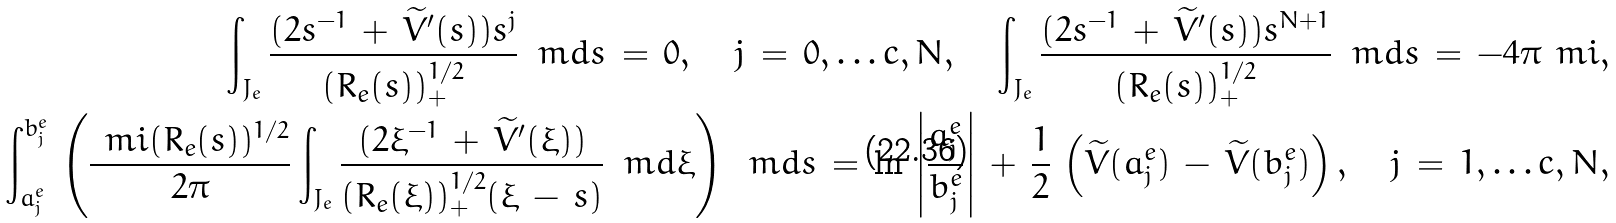Convert formula to latex. <formula><loc_0><loc_0><loc_500><loc_500>\int _ { J _ { e } } \frac { ( 2 s ^ { - 1 } \, + \, \widetilde { V } ^ { \prime } ( s ) ) s ^ { j } } { ( R _ { e } ( s ) ) ^ { 1 / 2 } _ { + } } \, \ m d s \, = \, 0 , \quad j \, = \, 0 , \dots c , N , \quad \int _ { J _ { e } } \frac { ( 2 s ^ { - 1 } \, + \, \widetilde { V } ^ { \prime } ( s ) ) s ^ { N + 1 } } { ( R _ { e } ( s ) ) ^ { 1 / 2 } _ { + } } \, \ m d s \, = \, - 4 \pi \ m i , \\ \int _ { a _ { j } ^ { e } } ^ { b _ { j } ^ { e } } \, \left ( \frac { \ m i ( R _ { e } ( s ) ) ^ { 1 / 2 } } { 2 \pi } \int _ { J _ { e } } \frac { ( 2 \xi ^ { - 1 } \, + \, \widetilde { V } ^ { \prime } ( \xi ) ) } { ( R _ { e } ( \xi ) ) ^ { 1 / 2 } _ { + } ( \xi \, - \, s ) } \, \ m d \xi \right ) \, \ m d s \, = \, \ln \, \left | \frac { a _ { j } ^ { e } } { b _ { j } ^ { e } } \right | \, + \, \frac { 1 } { 2 } \, \left ( \widetilde { V } ( a _ { j } ^ { e } ) \, - \, \widetilde { V } ( b _ { j } ^ { e } ) \right ) , \quad j \, = \, 1 , \dots c , N ,</formula> 